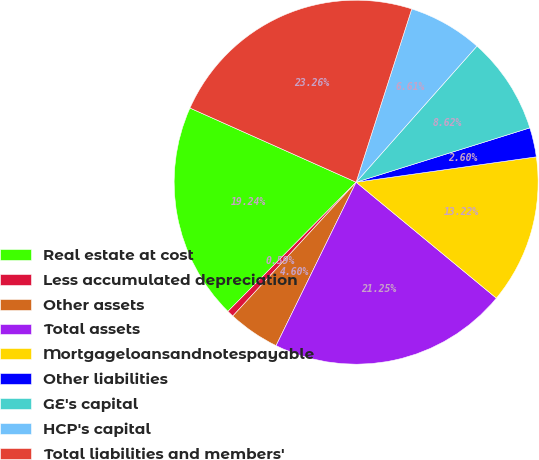Convert chart. <chart><loc_0><loc_0><loc_500><loc_500><pie_chart><fcel>Real estate at cost<fcel>Less accumulated depreciation<fcel>Other assets<fcel>Total assets<fcel>Mortgageloansandnotespayable<fcel>Other liabilities<fcel>GE's capital<fcel>HCP's capital<fcel>Total liabilities and members'<nl><fcel>19.24%<fcel>0.59%<fcel>4.6%<fcel>21.25%<fcel>13.22%<fcel>2.6%<fcel>8.62%<fcel>6.61%<fcel>23.26%<nl></chart> 